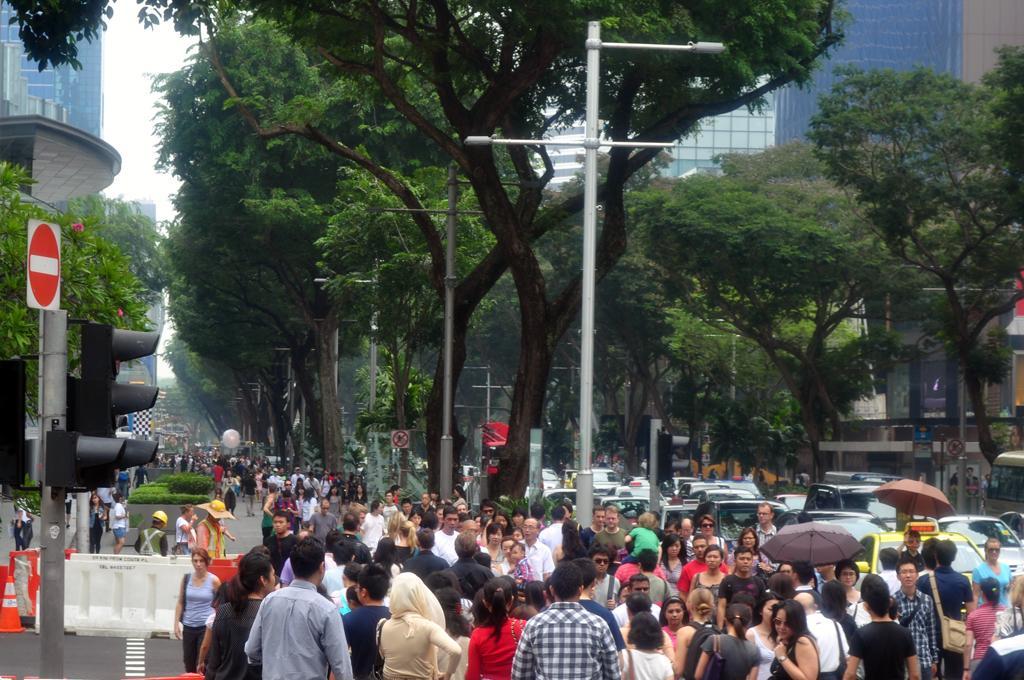How would you summarize this image in a sentence or two? This is the picture of a city. In this image there are group of people on the road and there are vehicles on the road. There are poles and trees and there are buildings. At the top there is sky. At the bottom there is a road and there are plants. 